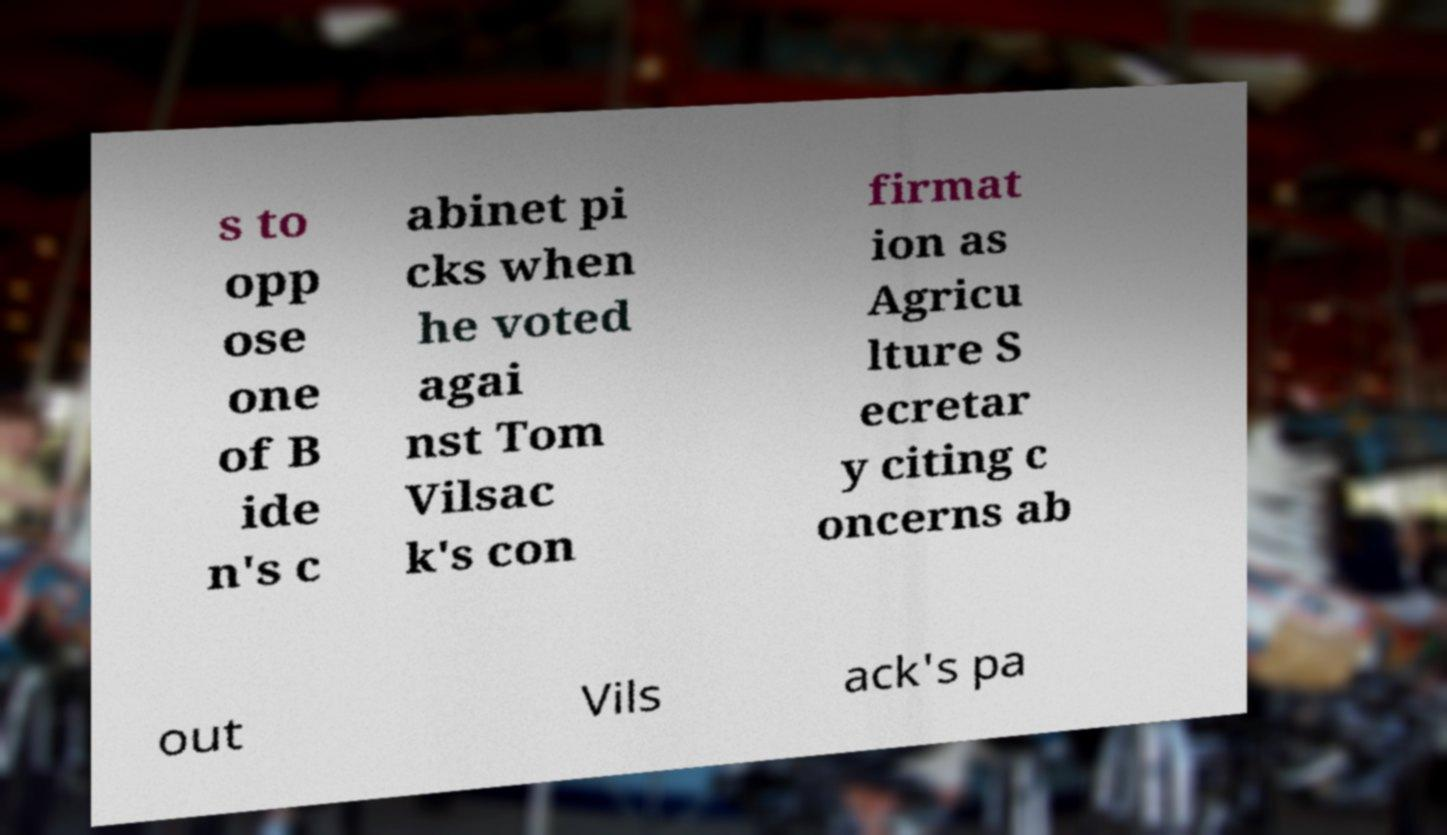Please read and relay the text visible in this image. What does it say? s to opp ose one of B ide n's c abinet pi cks when he voted agai nst Tom Vilsac k's con firmat ion as Agricu lture S ecretar y citing c oncerns ab out Vils ack's pa 